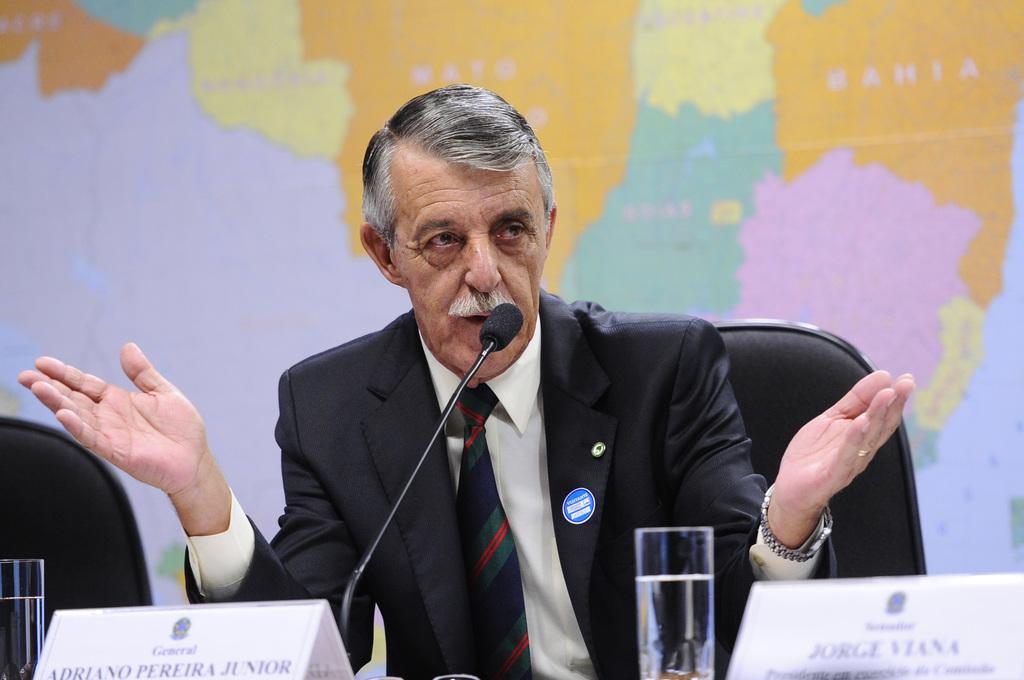Can you describe this image briefly? In the picture we can see a man sitting in the chair near the table on it, and he is wearing a blazer with shirt and tie and talking into the microphone on the desk, on it we can see a glass of water and a name board, in the background we can see a map on the wall. 